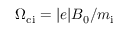<formula> <loc_0><loc_0><loc_500><loc_500>\Omega _ { c i } = | e | B _ { 0 } / m _ { i }</formula> 